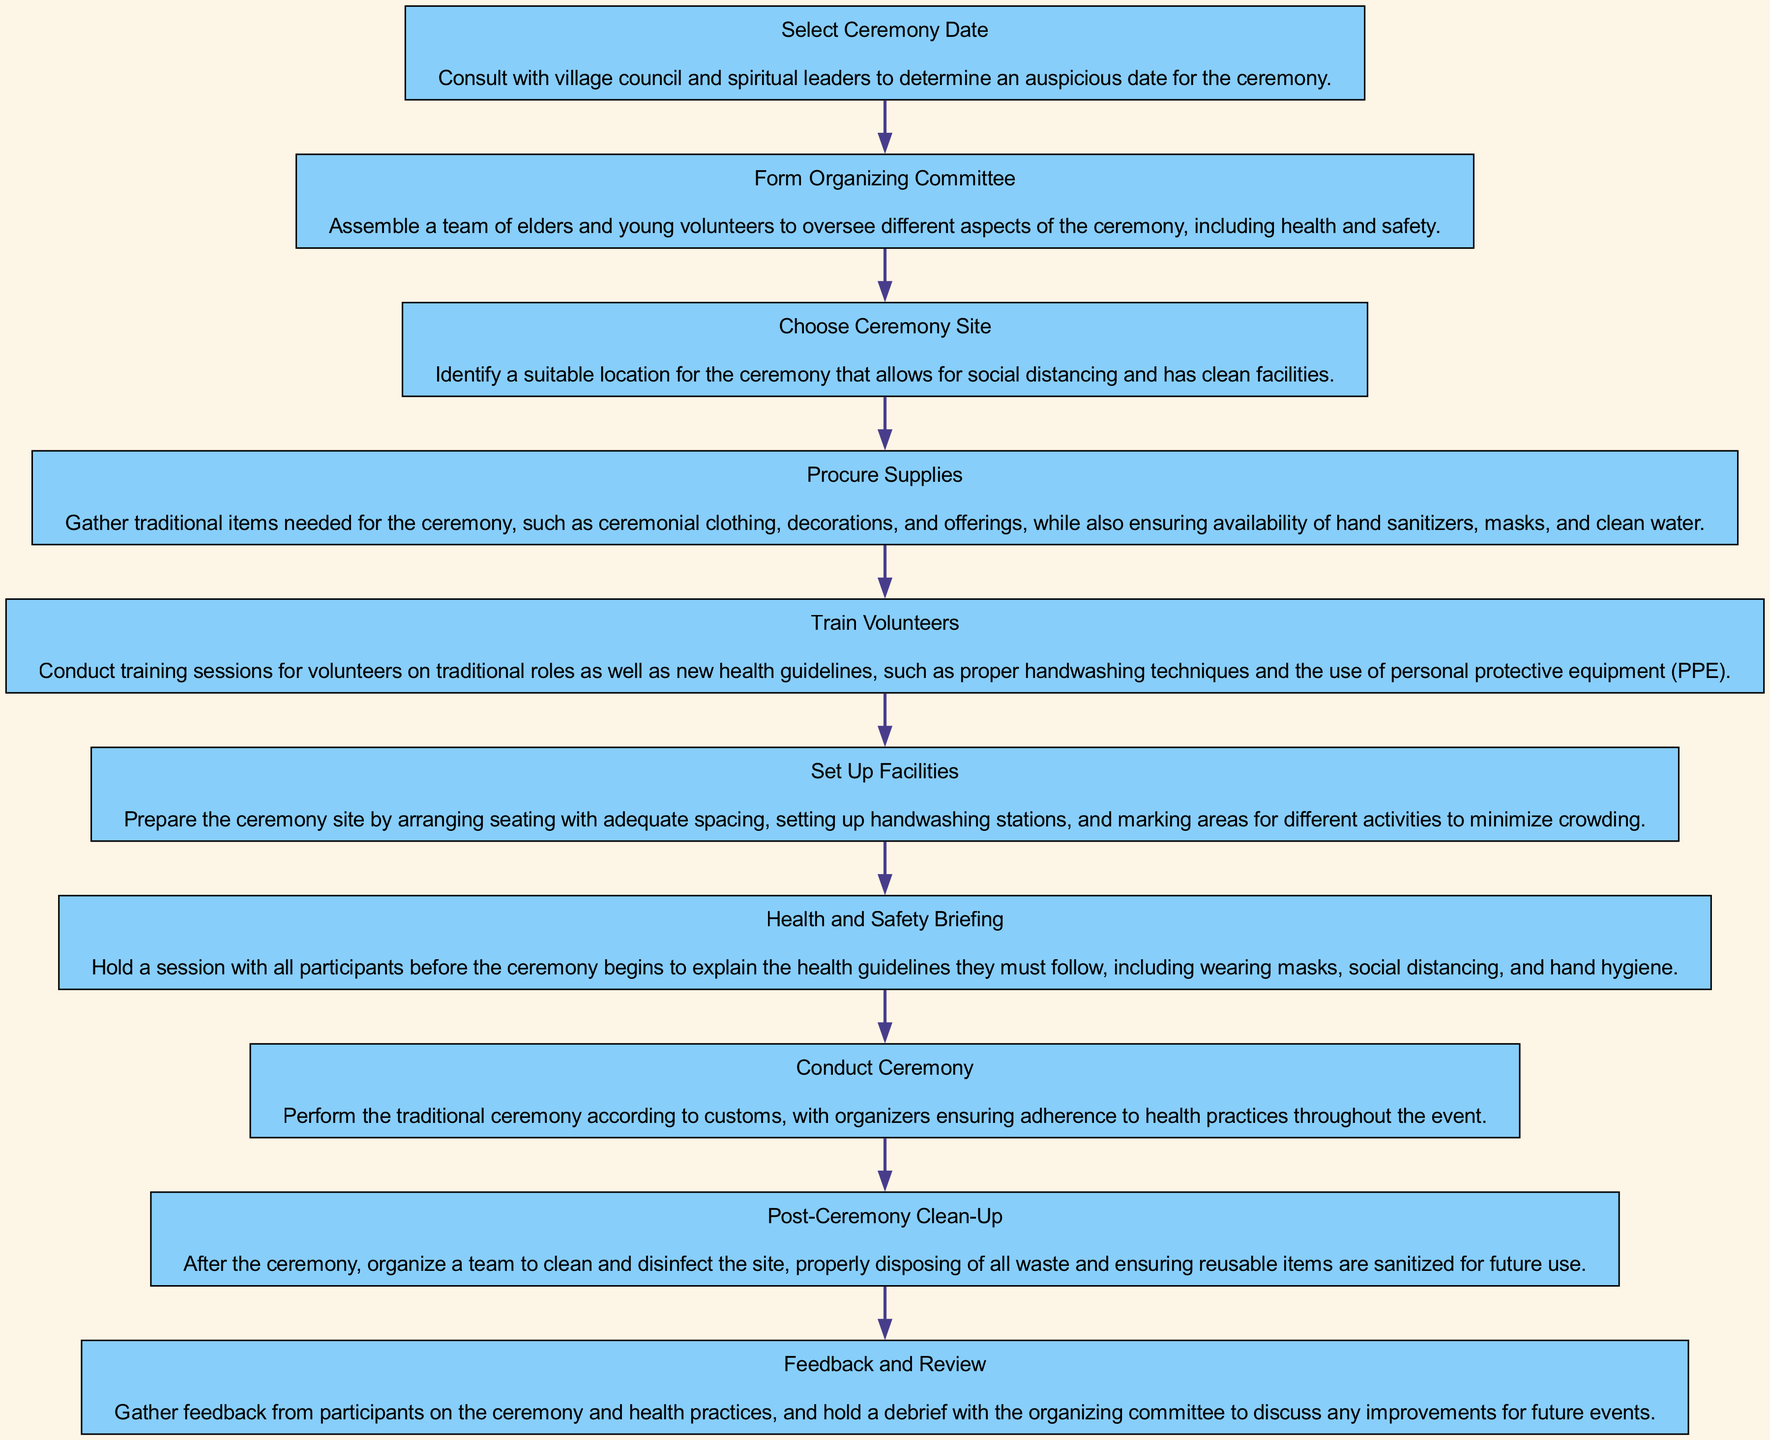What is the first step in planning the ceremony? The first step is to "Select Ceremony Date." It is shown as the first node in the diagram, outlining the action of consulting with the village council and spiritual leaders.
Answer: Select Ceremony Date How many nodes are there in the diagram? By counting the number of distinct steps listed in the diagram, we find a total of 10 nodes representing each step in the planning process.
Answer: 10 What is the last action that occurs after the ceremony? The last action is "Feedback and Review," which is the last node in the diagram where feedback is gathered and a debrief is held.
Answer: Feedback and Review Which step involves training for volunteers? The step titled "Train Volunteers" specifically mentions conducting training sessions for volunteers concerning traditional roles and health guidelines.
Answer: Train Volunteers What is the purpose of the "Health and Safety Briefing"? The purpose of this step is to ensure all participants understand the health guidelines they must follow before the ceremony commences.
Answer: Explain health guidelines What action follows "Set Up Facilities"? The action that directly follows "Set Up Facilities" is "Health and Safety Briefing," indicating that preparations lead into educating participants.
Answer: Health and Safety Briefing How many actions involve the organization of the site? There are three actions related to the organization of the site: "Choose Ceremony Site," "Set Up Facilities," and "Post-Ceremony Clean-Up."
Answer: Three What is the focus of the "Procure Supplies" step? This step focuses on gathering both traditional items and the necessary health supplies for the ceremony, ensuring safe conditions while respecting traditions.
Answer: Gather traditional items What action ensures that participants adhere to health practices during the ceremony? The action "Conduct Ceremony" emphasizes performing the ceremony while ensuring adherence to health practices throughout the event.
Answer: Conduct Ceremony Which action comes immediately after forming the organizing committee? "Choose Ceremony Site" is the step that follows immediately after "Form Organizing Committee," indicating a sequence in the planning process.
Answer: Choose Ceremony Site 